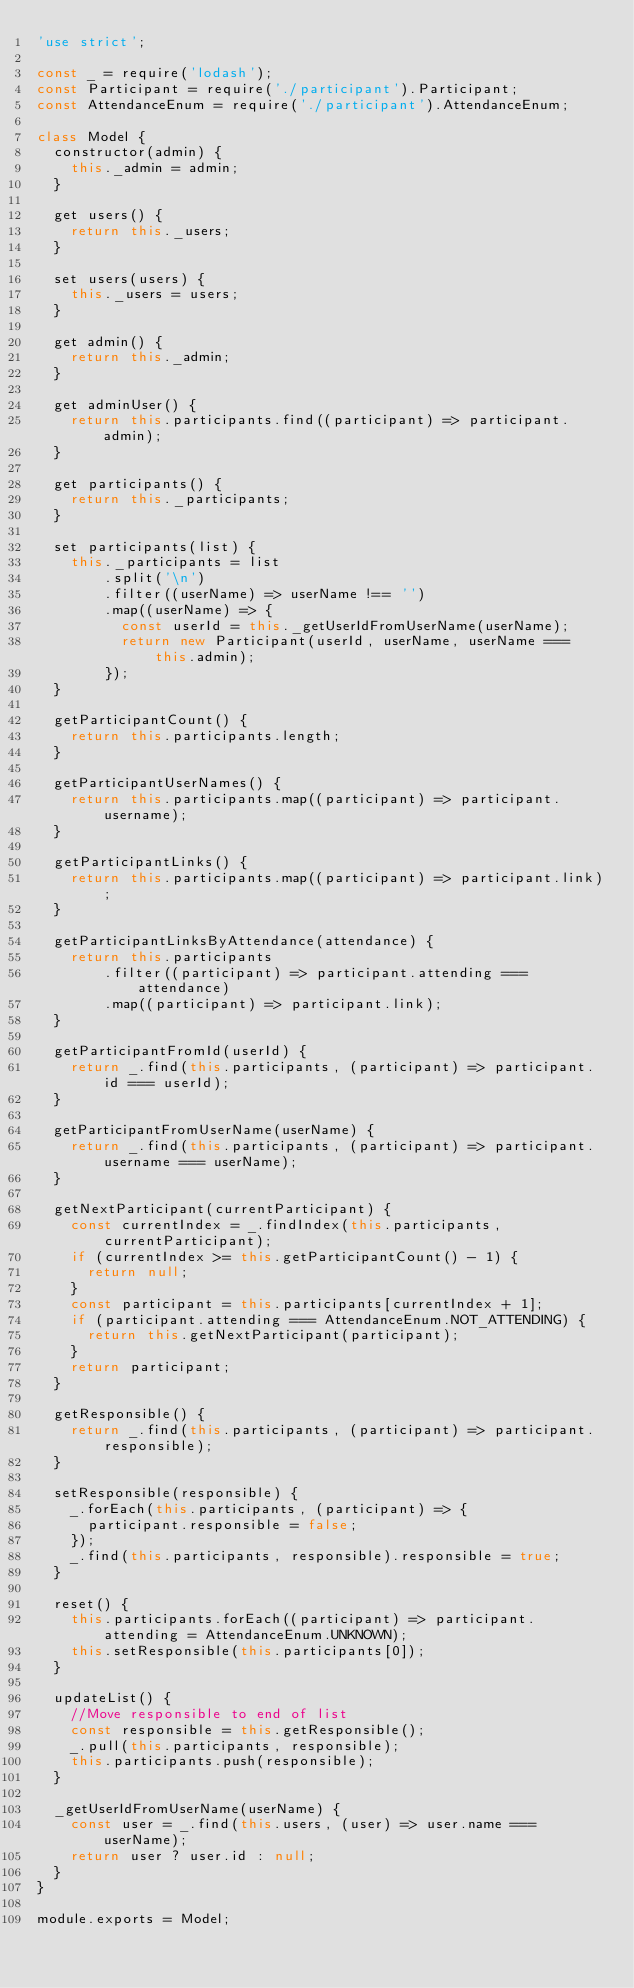<code> <loc_0><loc_0><loc_500><loc_500><_JavaScript_>'use strict';

const _ = require('lodash');
const Participant = require('./participant').Participant;
const AttendanceEnum = require('./participant').AttendanceEnum;

class Model {
  constructor(admin) {
    this._admin = admin;
  }

  get users() {
    return this._users;
  }

  set users(users) {
    this._users = users;
  }

  get admin() {
    return this._admin;
  }

  get adminUser() {
    return this.participants.find((participant) => participant.admin);
  }

  get participants() {
    return this._participants;
  }

  set participants(list) {
    this._participants = list
        .split('\n')
        .filter((userName) => userName !== '')
        .map((userName) => {
          const userId = this._getUserIdFromUserName(userName);
          return new Participant(userId, userName, userName === this.admin);
        });
  }

  getParticipantCount() {
    return this.participants.length;
  }

  getParticipantUserNames() {
    return this.participants.map((participant) => participant.username);
  }

  getParticipantLinks() {
    return this.participants.map((participant) => participant.link);
  }

  getParticipantLinksByAttendance(attendance) {
    return this.participants
        .filter((participant) => participant.attending === attendance)
        .map((participant) => participant.link);
  }

  getParticipantFromId(userId) {
    return _.find(this.participants, (participant) => participant.id === userId);
  }

  getParticipantFromUserName(userName) {
    return _.find(this.participants, (participant) => participant.username === userName);
  }

  getNextParticipant(currentParticipant) {
    const currentIndex = _.findIndex(this.participants, currentParticipant);
    if (currentIndex >= this.getParticipantCount() - 1) {
      return null;
    }
    const participant = this.participants[currentIndex + 1];
    if (participant.attending === AttendanceEnum.NOT_ATTENDING) {
      return this.getNextParticipant(participant);
    }
    return participant;
  }

  getResponsible() {
    return _.find(this.participants, (participant) => participant.responsible);
  }

  setResponsible(responsible) {
    _.forEach(this.participants, (participant) => {
      participant.responsible = false;
    });
    _.find(this.participants, responsible).responsible = true;
  }

  reset() {
    this.participants.forEach((participant) => participant.attending = AttendanceEnum.UNKNOWN);
    this.setResponsible(this.participants[0]);
  }

  updateList() {
    //Move responsible to end of list
    const responsible = this.getResponsible();
    _.pull(this.participants, responsible);
    this.participants.push(responsible);
  }

  _getUserIdFromUserName(userName) {
    const user = _.find(this.users, (user) => user.name === userName);
    return user ? user.id : null;
  }
}

module.exports = Model;
</code> 